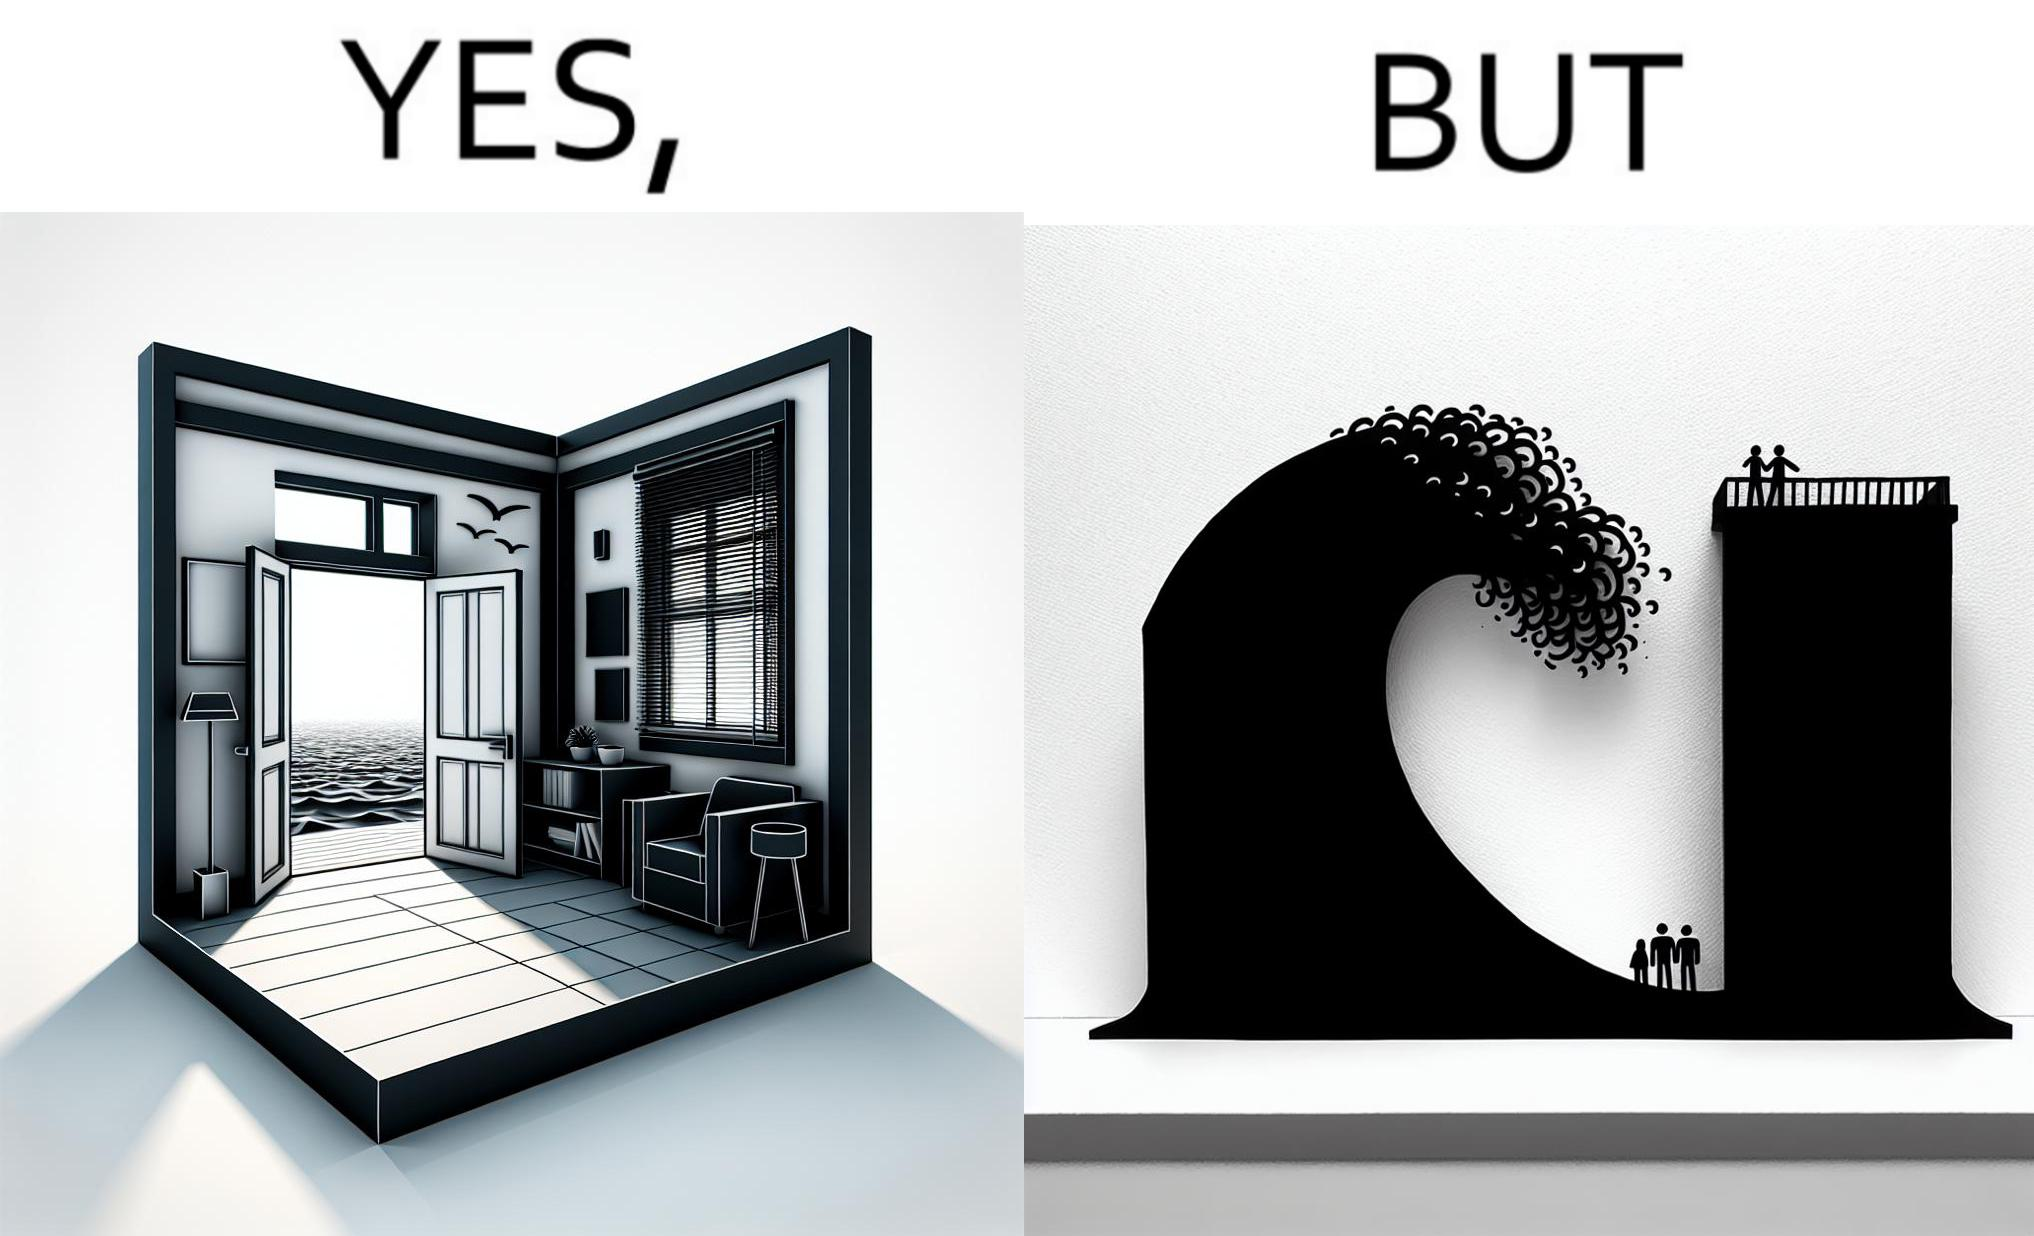Would you classify this image as satirical? Yes, this image is satirical. 